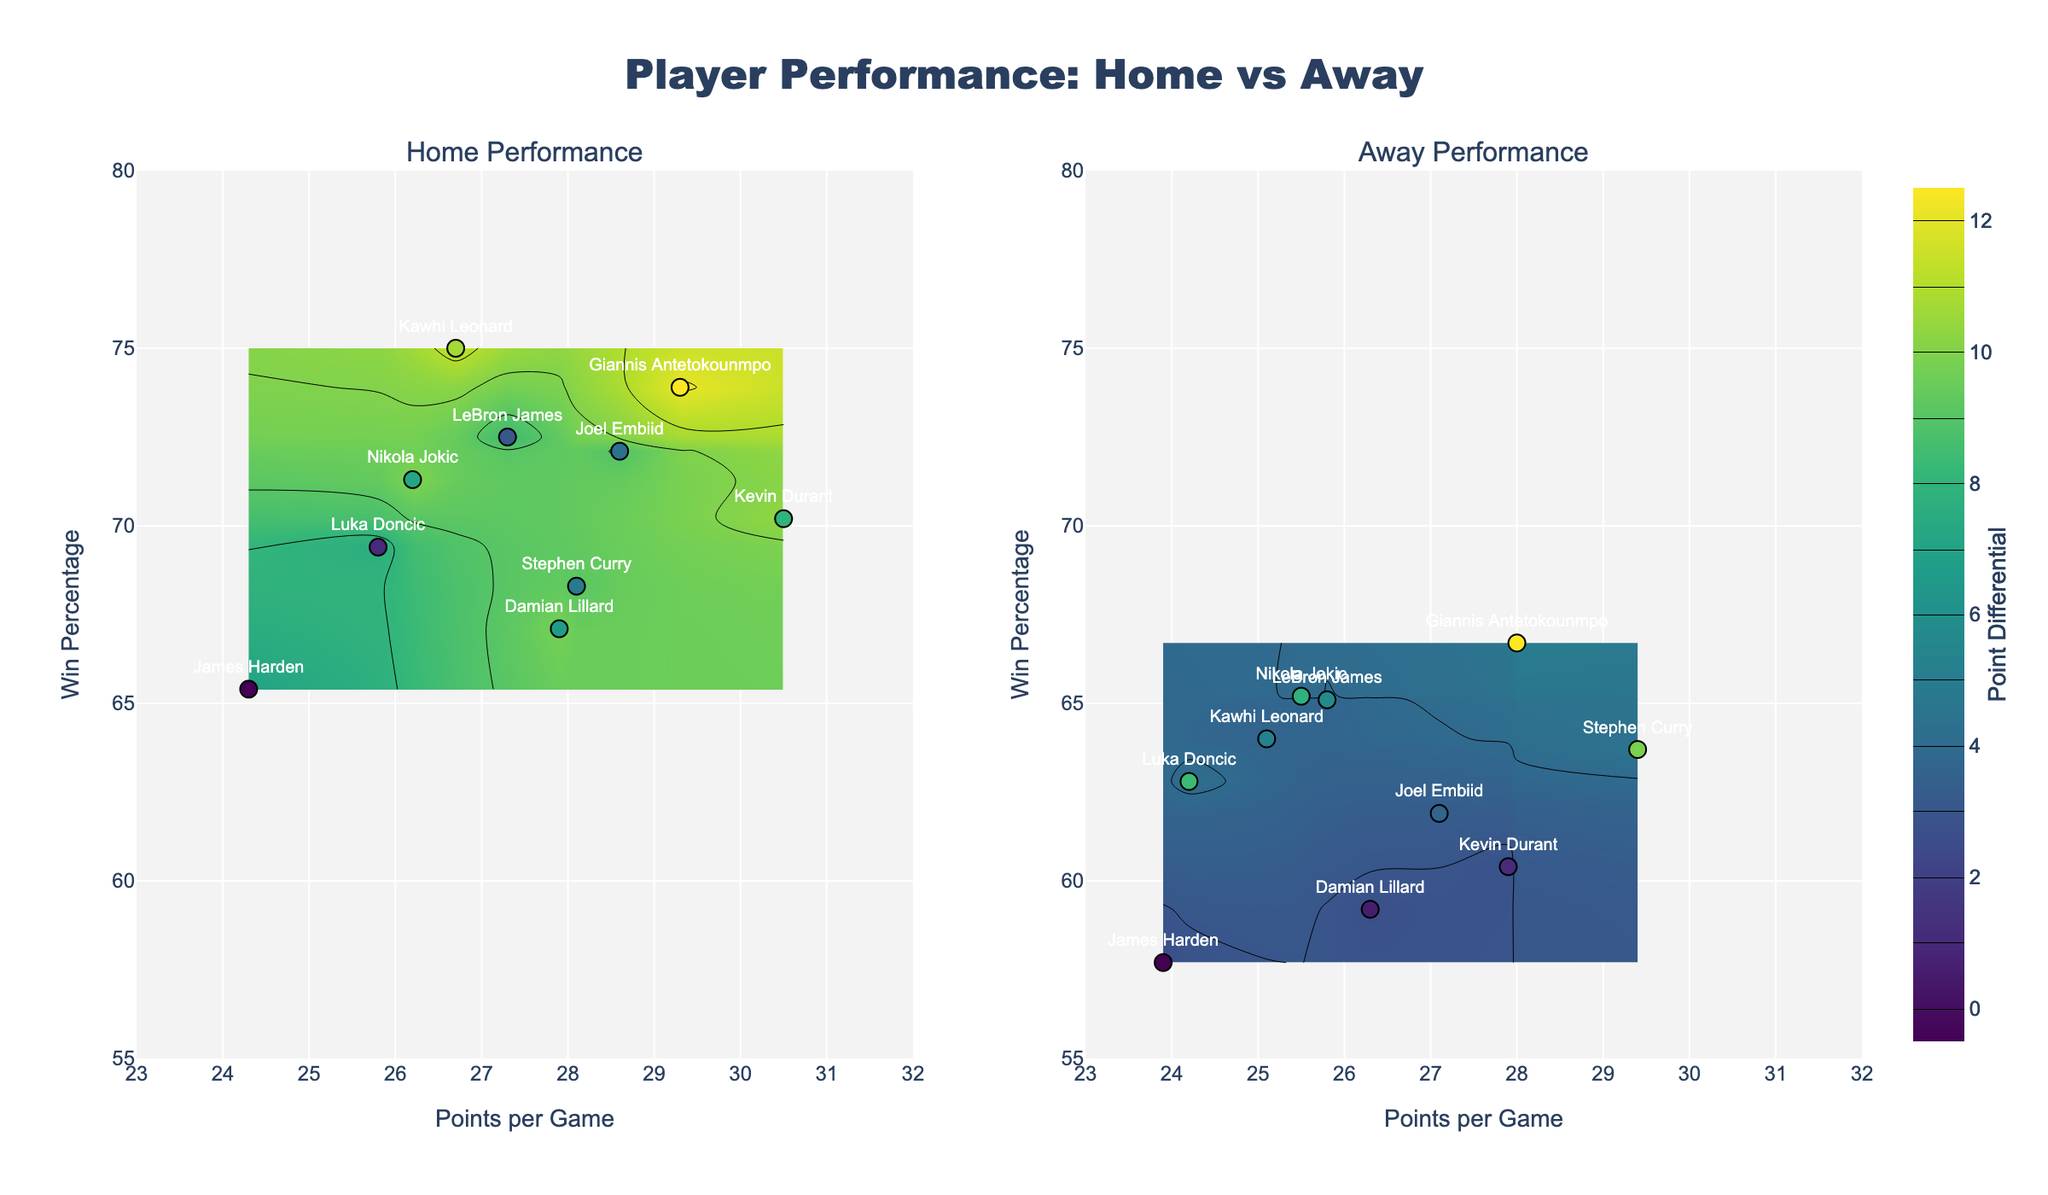What is the title of the plot? The title of the plot is usually displayed prominently at the top of the figure. Here, the title is "Player Performance: Home vs Away".
Answer: Player Performance: Home vs Away How many subplots are there? There are two distinct contour plots side by side, one for "Home Performance" and one for "Away Performance".
Answer: 2 Which player has the highest point differential at home? From the home performance subplot, locate the highest z-value (point differential). Giannis Antetokounmpo has the highest home point differential of 12.1.
Answer: Giannis Antetokounmpo Who has a higher Win Percentage in Away games, LeBron James or Stephen Curry? Identify the win percentage values for both players from the away performance subplot. LeBron James has 65.1% and Stephen Curry has 63.7%.
Answer: LeBron James What is the color scale used in the contour plots? Observing the contour plots, the color scale used transitions from light to dark shades of a single color range, indicated as 'Viridis'.
Answer: Viridis Which player has the lowest away point differential? In the subplot for away performance, find the smallest z-value. James Harden has the lowest away point differential of 2.5.
Answer: James Harden Does Kevin Durant score more points at home or away? Compare Kevin Durant’s points per game in both subplots. At home, he scores 30.5 points per game, and away, he scores 27.9 points per game.
Answer: Home Which subplot contains more players with a win percentage above 70%? Counting the number of players with a win percentage above 70% in both subplots, the home subplot has more players (LeBron James, Giannis Antetokounmpo, and Kawhi Leonard).
Answer: Home Performance Calculate the average home point differential for all players shown. Sum the home point differentials (8.4 + 9.1 + 10.3 + 12.1 + 7.6 + 11.4 + 9.8 + 7.0 + 10.0 + 8.9) and divide by the number of players (10). The total is 94.6, and the average is 94.6/10 = 9.46.
Answer: 9.46 